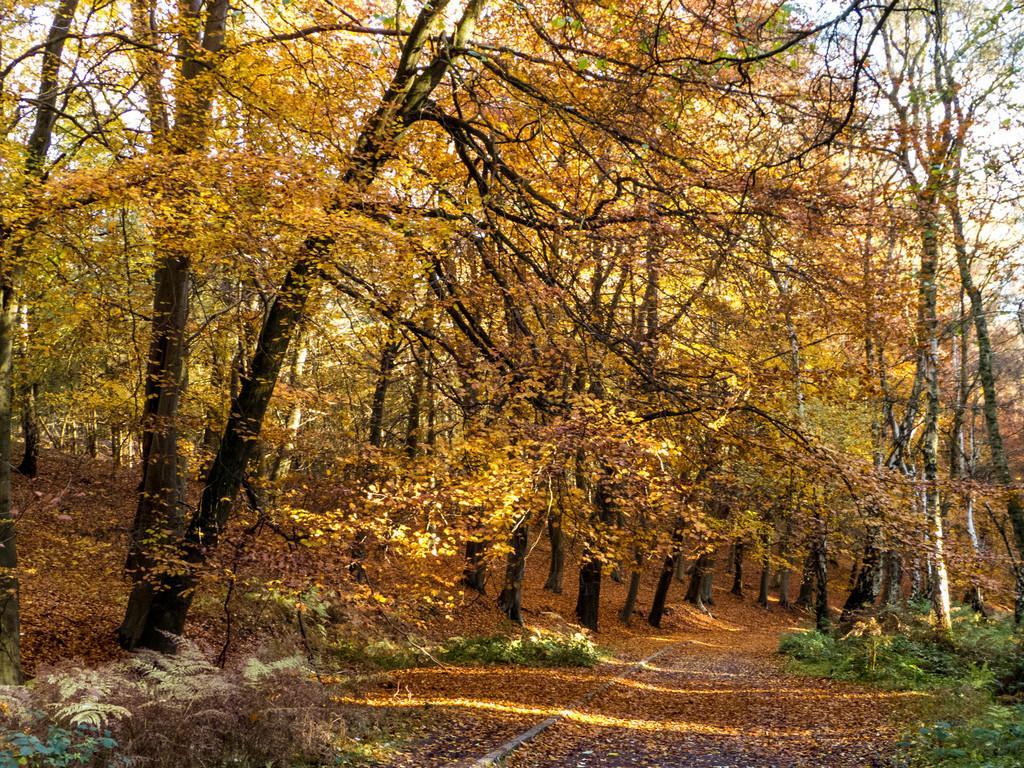What is covering the grass in the image? The grass is covered with dry leaves. What type of vegetation can be seen in the image? There are plants and trees visible in the image. What type of pancake is being served on the tongue of the person in the image? There is no person or pancake present in the image; it features grass covered with dry leaves and plants and trees in the background. 